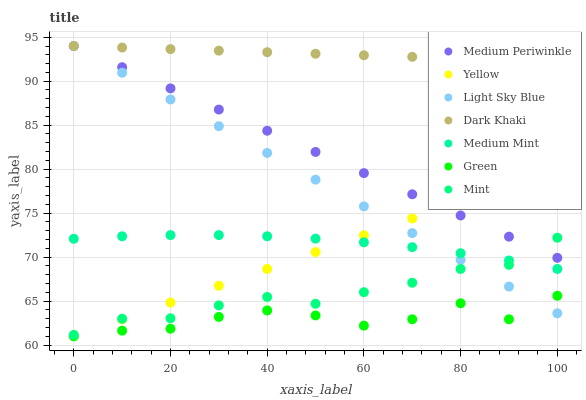Does Green have the minimum area under the curve?
Answer yes or no. Yes. Does Dark Khaki have the maximum area under the curve?
Answer yes or no. Yes. Does Medium Periwinkle have the minimum area under the curve?
Answer yes or no. No. Does Medium Periwinkle have the maximum area under the curve?
Answer yes or no. No. Is Medium Periwinkle the smoothest?
Answer yes or no. Yes. Is Green the roughest?
Answer yes or no. Yes. Is Yellow the smoothest?
Answer yes or no. No. Is Yellow the roughest?
Answer yes or no. No. Does Yellow have the lowest value?
Answer yes or no. Yes. Does Medium Periwinkle have the lowest value?
Answer yes or no. No. Does Light Sky Blue have the highest value?
Answer yes or no. Yes. Does Yellow have the highest value?
Answer yes or no. No. Is Yellow less than Dark Khaki?
Answer yes or no. Yes. Is Medium Periwinkle greater than Green?
Answer yes or no. Yes. Does Yellow intersect Medium Mint?
Answer yes or no. Yes. Is Yellow less than Medium Mint?
Answer yes or no. No. Is Yellow greater than Medium Mint?
Answer yes or no. No. Does Yellow intersect Dark Khaki?
Answer yes or no. No. 